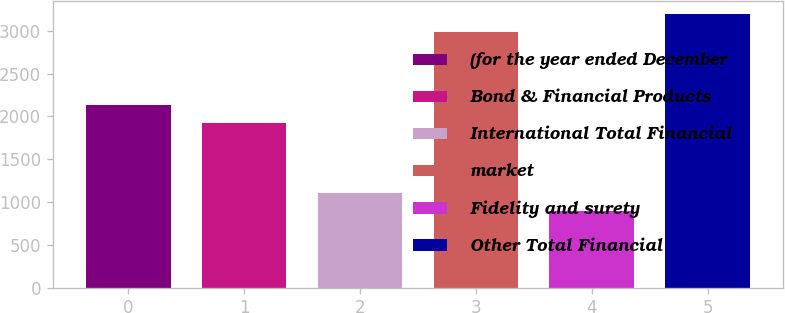Convert chart to OTSL. <chart><loc_0><loc_0><loc_500><loc_500><bar_chart><fcel>(for the year ended December<fcel>Bond & Financial Products<fcel>International Total Financial<fcel>market<fcel>Fidelity and surety<fcel>Other Total Financial<nl><fcel>2132.6<fcel>1924<fcel>1103.6<fcel>2981<fcel>895<fcel>3189.6<nl></chart> 